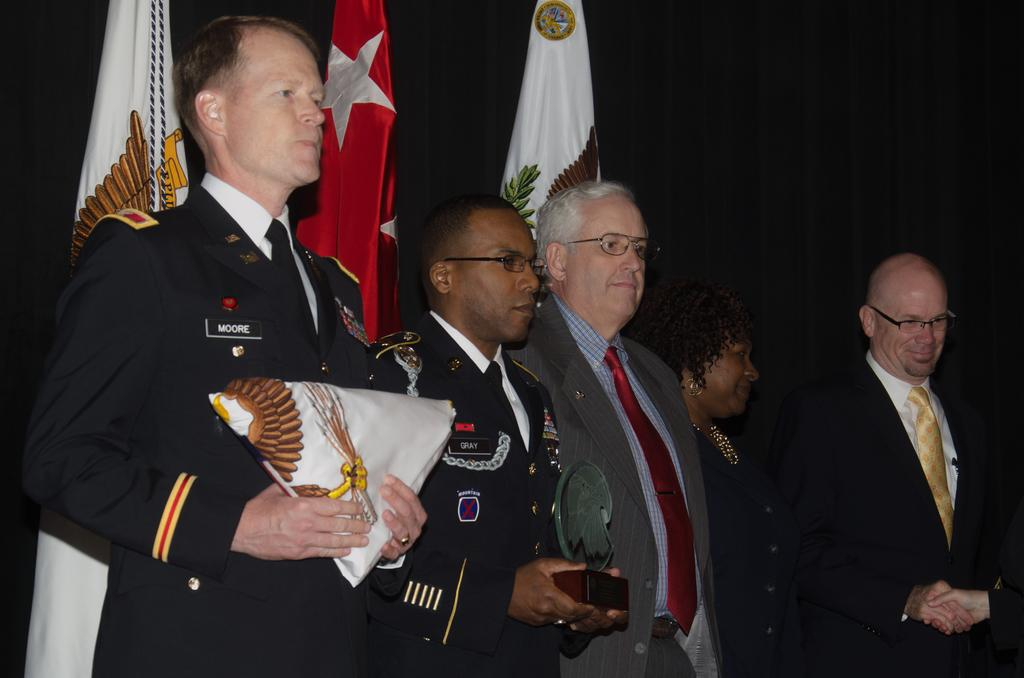What is happening in the image? There are people standing in the image. What are the people holding in their hands? Some of the people are holding objects in their hands. What can be seen in the background of the image? There are flags in the background of the image. How would you describe the background of the image? The background of the image is blurred. What type of appliance can be seen running in the image? There is no appliance present in the image, and therefore no such activity can be observed. 